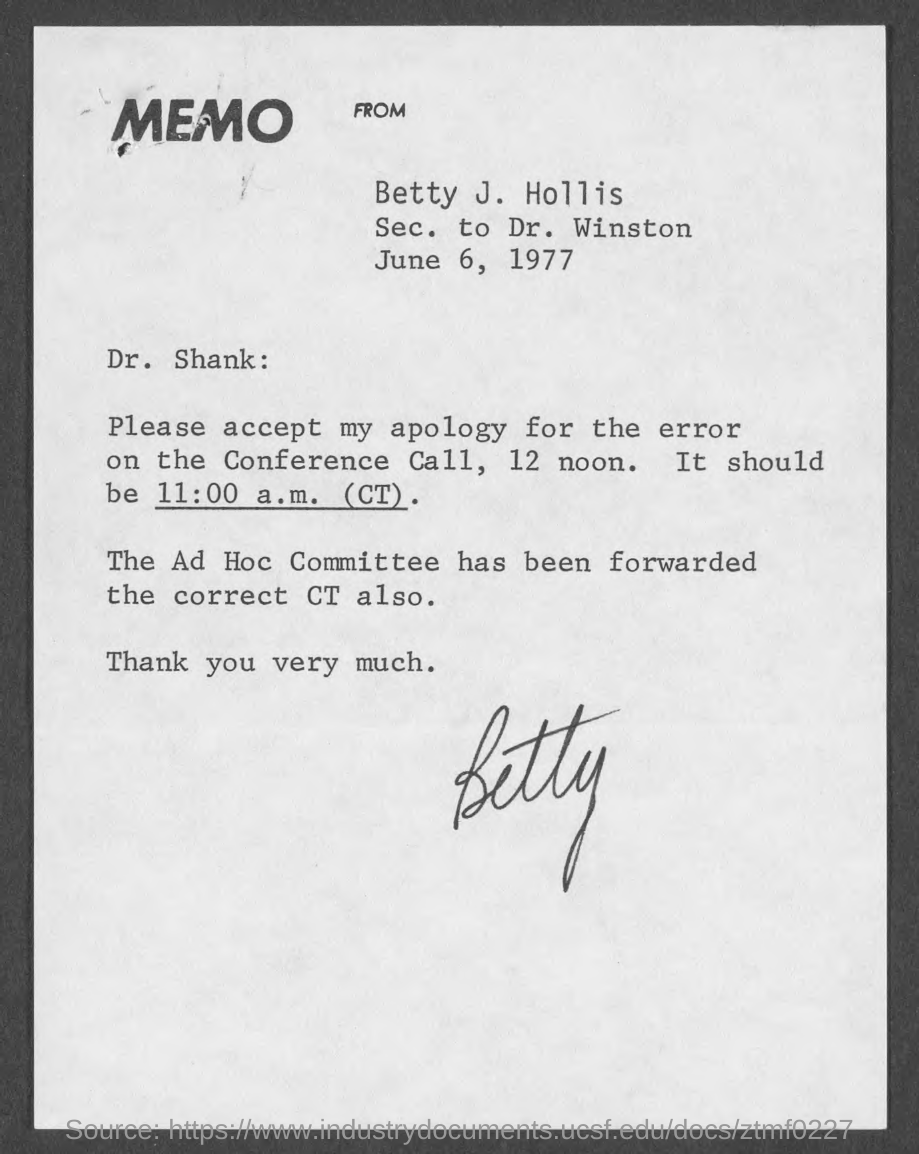When is the memo dated?
Give a very brief answer. June 6, 1977. Who is sec. to dr. winston?
Keep it short and to the point. Betty J. Hollis. 